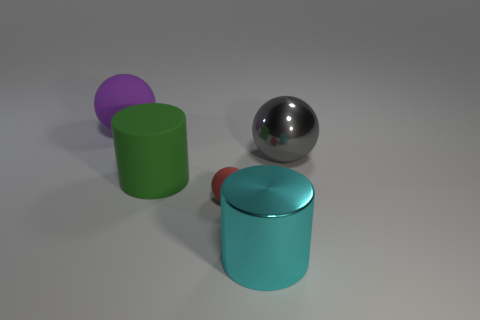What number of things are big things in front of the purple thing or tiny red matte spheres?
Provide a succinct answer. 4. What color is the tiny object?
Your answer should be very brief. Red. What is the sphere that is to the left of the red thing made of?
Your answer should be compact. Rubber. There is a big purple rubber object; is its shape the same as the large metal thing that is to the right of the large cyan cylinder?
Your answer should be very brief. Yes. Is the number of large gray objects greater than the number of tiny gray cylinders?
Your answer should be very brief. Yes. Is there any other thing that is the same color as the small ball?
Provide a short and direct response. No. What shape is the other thing that is made of the same material as the cyan object?
Make the answer very short. Sphere. There is a big gray sphere on the right side of the rubber ball that is left of the green cylinder; what is it made of?
Your answer should be very brief. Metal. Does the tiny matte object that is in front of the purple matte ball have the same shape as the big green rubber object?
Provide a short and direct response. No. Are there more large purple rubber objects that are left of the large shiny cylinder than tiny red things?
Keep it short and to the point. No. 